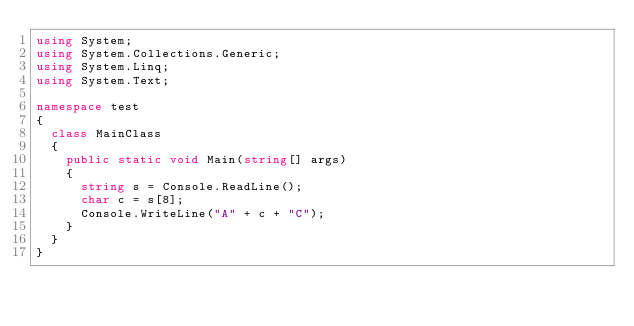Convert code to text. <code><loc_0><loc_0><loc_500><loc_500><_C#_>using System;
using System.Collections.Generic;
using System.Linq;
using System.Text;

namespace test
{
	class MainClass
	{
		public static void Main(string[] args)
		{
			string s = Console.ReadLine();
			char c = s[8];
			Console.WriteLine("A" + c + "C");
		}
	}
}
</code> 